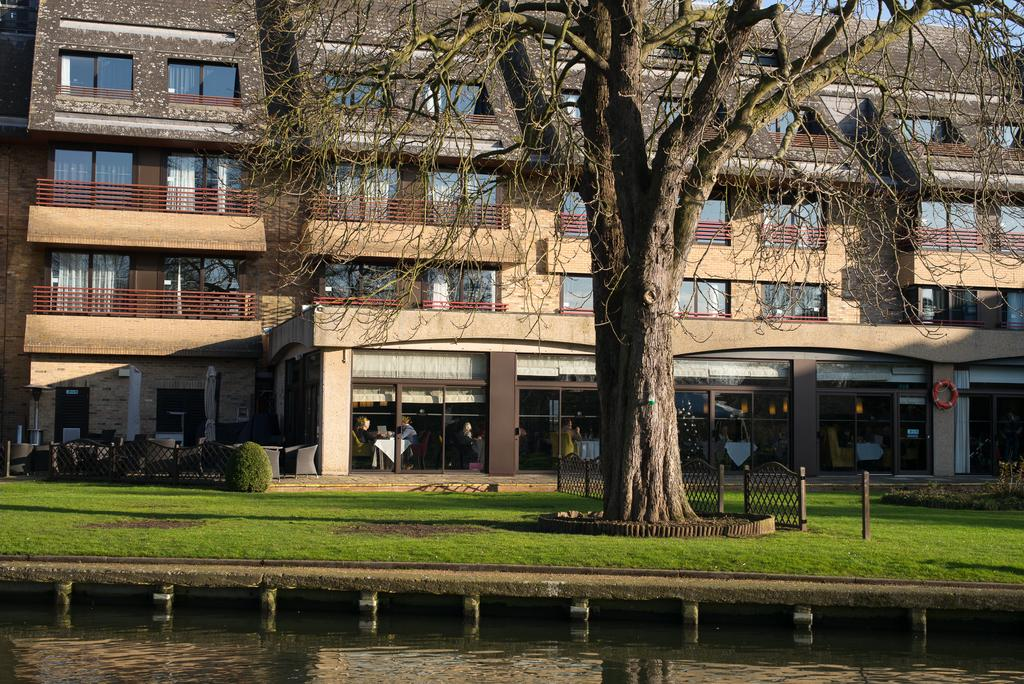What is visible in the image? Water is visible in the image. What can be seen in the background of the image? There is a building, trees, and grass in the background of the image. What color is the building in the background? The building is cream-colored. What color are the trees and grass in the background? The trees and grass are green. What type of windows can be seen in the image? There are glass windows visible in the image. How many yards are there in the image? There is no mention of a yard in the image, so it is not possible to determine the number of yards. 